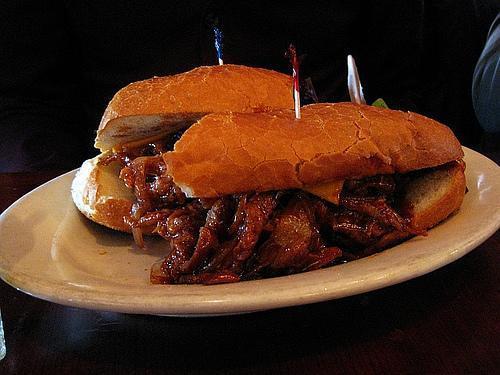How many dining tables are there?
Give a very brief answer. 1. How many sandwiches are there?
Give a very brief answer. 2. How many people on the vase are holding a vase?
Give a very brief answer. 0. 